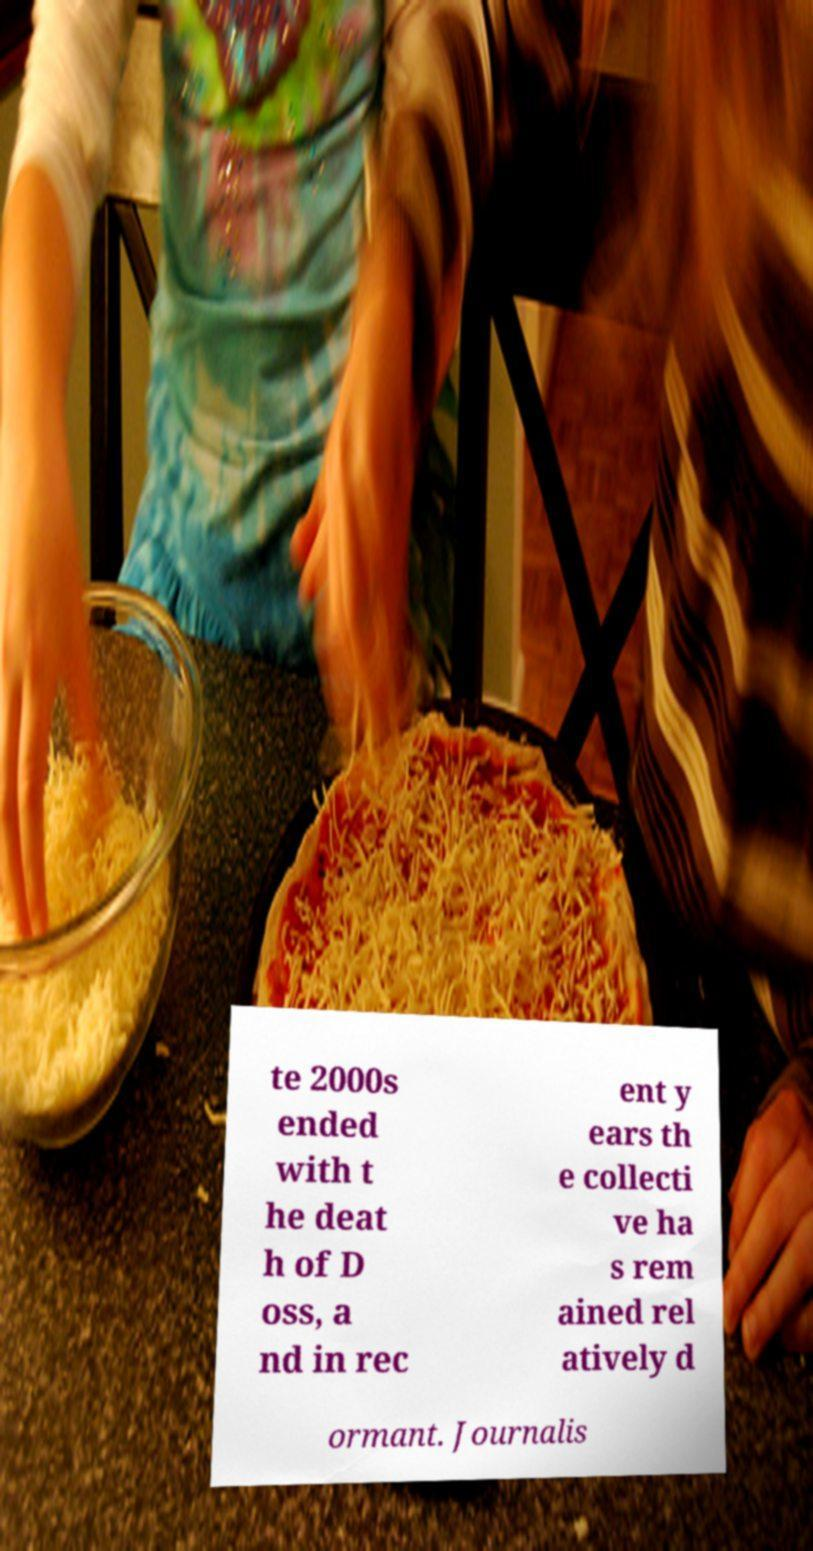Please identify and transcribe the text found in this image. te 2000s ended with t he deat h of D oss, a nd in rec ent y ears th e collecti ve ha s rem ained rel atively d ormant. Journalis 